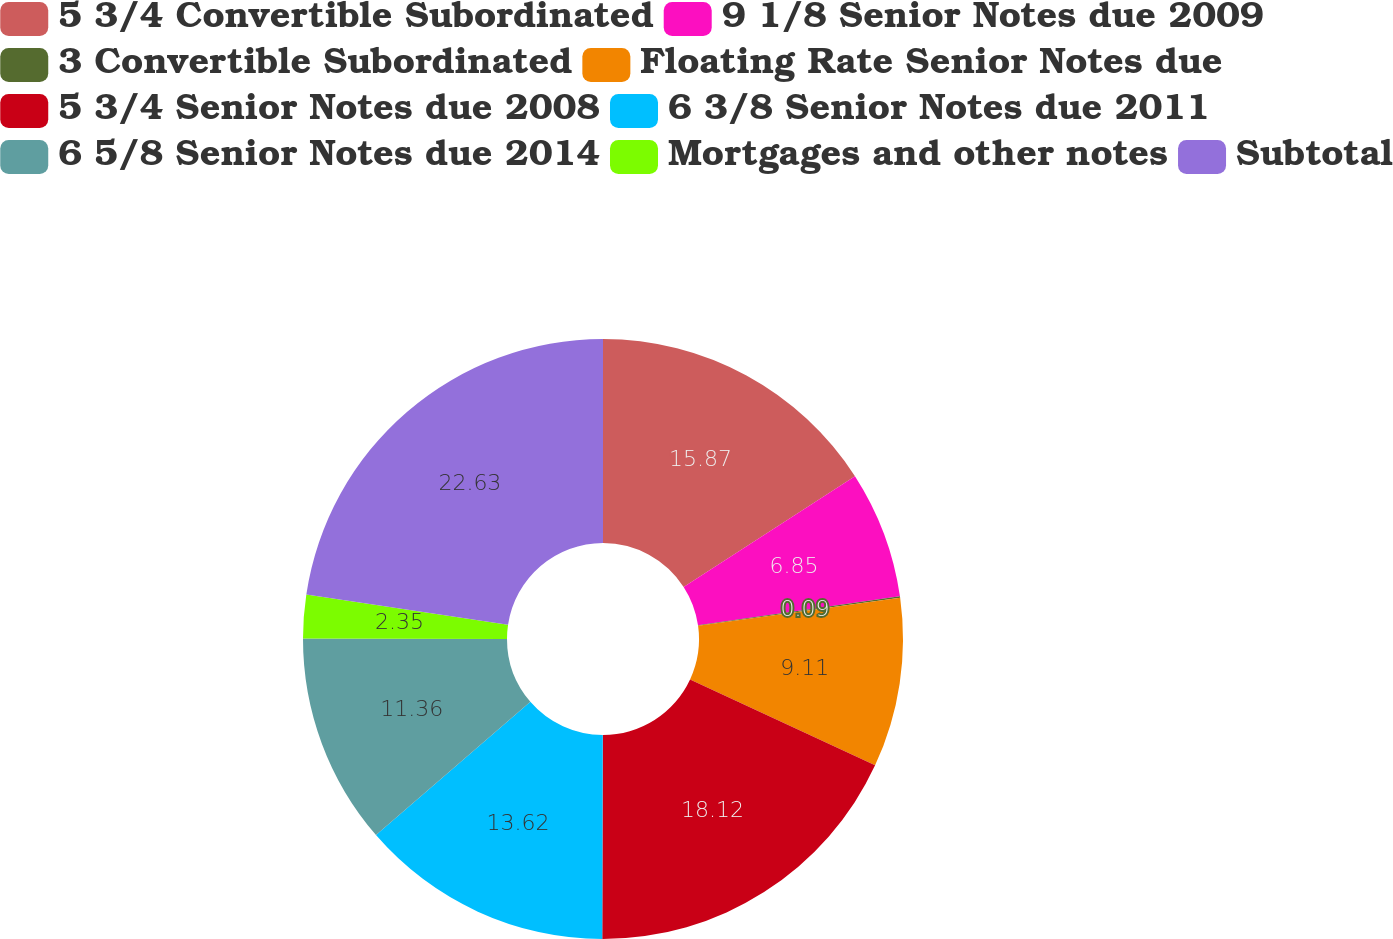Convert chart. <chart><loc_0><loc_0><loc_500><loc_500><pie_chart><fcel>5 3/4 Convertible Subordinated<fcel>9 1/8 Senior Notes due 2009<fcel>3 Convertible Subordinated<fcel>Floating Rate Senior Notes due<fcel>5 3/4 Senior Notes due 2008<fcel>6 3/8 Senior Notes due 2011<fcel>6 5/8 Senior Notes due 2014<fcel>Mortgages and other notes<fcel>Subtotal<nl><fcel>15.87%<fcel>6.85%<fcel>0.09%<fcel>9.11%<fcel>18.12%<fcel>13.62%<fcel>11.36%<fcel>2.35%<fcel>22.63%<nl></chart> 